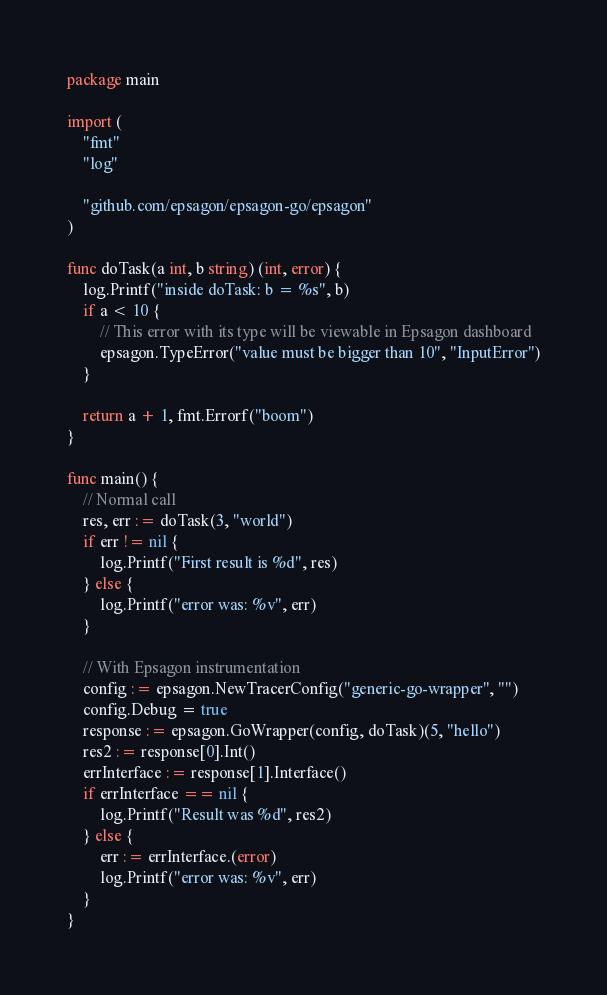<code> <loc_0><loc_0><loc_500><loc_500><_Go_>package main

import (
	"fmt"
	"log"

	"github.com/epsagon/epsagon-go/epsagon"
)

func doTask(a int, b string) (int, error) {
	log.Printf("inside doTask: b = %s", b)
	if a < 10 {
		// This error with its type will be viewable in Epsagon dashboard
		epsagon.TypeError("value must be bigger than 10", "InputError")
	}

	return a + 1, fmt.Errorf("boom")
}

func main() {
	// Normal call
	res, err := doTask(3, "world")
	if err != nil {
		log.Printf("First result is %d", res)
	} else {
		log.Printf("error was: %v", err)
	}

	// With Epsagon instrumentation
	config := epsagon.NewTracerConfig("generic-go-wrapper", "")
	config.Debug = true
	response := epsagon.GoWrapper(config, doTask)(5, "hello")
	res2 := response[0].Int()
	errInterface := response[1].Interface()
	if errInterface == nil {
		log.Printf("Result was %d", res2)
	} else {
		err := errInterface.(error)
		log.Printf("error was: %v", err)
	}
}
</code> 